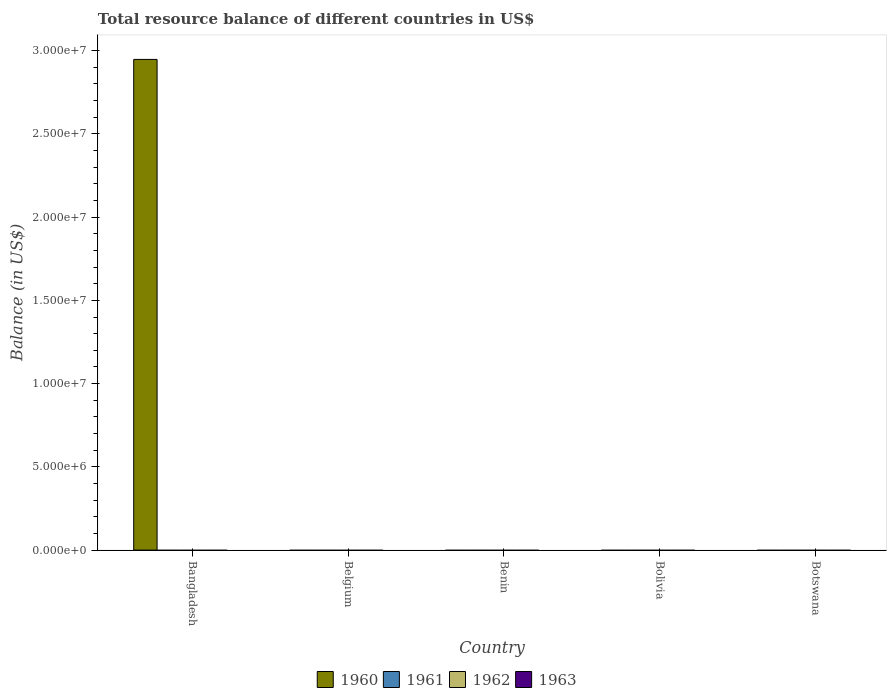How many different coloured bars are there?
Your answer should be compact. 1. How many bars are there on the 2nd tick from the right?
Ensure brevity in your answer.  0. What is the label of the 3rd group of bars from the left?
Offer a very short reply. Benin. What is the total resource balance in 1962 in Belgium?
Provide a succinct answer. 0. Across all countries, what is the maximum total resource balance in 1960?
Make the answer very short. 2.95e+07. Across all countries, what is the minimum total resource balance in 1961?
Your answer should be compact. 0. What is the total total resource balance in 1963 in the graph?
Make the answer very short. 0. What is the difference between the total resource balance in 1963 in Benin and the total resource balance in 1960 in Bangladesh?
Your response must be concise. -2.95e+07. What is the average total resource balance in 1960 per country?
Offer a terse response. 5.89e+06. In how many countries, is the total resource balance in 1960 greater than 19000000 US$?
Provide a short and direct response. 1. What is the difference between the highest and the lowest total resource balance in 1960?
Provide a succinct answer. 2.95e+07. Is it the case that in every country, the sum of the total resource balance in 1962 and total resource balance in 1961 is greater than the sum of total resource balance in 1960 and total resource balance in 1963?
Offer a very short reply. No. How many countries are there in the graph?
Ensure brevity in your answer.  5. What is the difference between two consecutive major ticks on the Y-axis?
Your answer should be very brief. 5.00e+06. Are the values on the major ticks of Y-axis written in scientific E-notation?
Your answer should be very brief. Yes. Does the graph contain grids?
Offer a terse response. No. How many legend labels are there?
Provide a short and direct response. 4. What is the title of the graph?
Keep it short and to the point. Total resource balance of different countries in US$. Does "2009" appear as one of the legend labels in the graph?
Provide a short and direct response. No. What is the label or title of the X-axis?
Provide a short and direct response. Country. What is the label or title of the Y-axis?
Your answer should be compact. Balance (in US$). What is the Balance (in US$) in 1960 in Bangladesh?
Your answer should be very brief. 2.95e+07. What is the Balance (in US$) in 1960 in Belgium?
Give a very brief answer. 0. What is the Balance (in US$) in 1961 in Belgium?
Provide a short and direct response. 0. What is the Balance (in US$) in 1962 in Belgium?
Keep it short and to the point. 0. What is the Balance (in US$) in 1963 in Belgium?
Keep it short and to the point. 0. What is the Balance (in US$) in 1960 in Bolivia?
Your answer should be very brief. 0. What is the Balance (in US$) in 1961 in Bolivia?
Offer a terse response. 0. What is the Balance (in US$) in 1962 in Bolivia?
Give a very brief answer. 0. What is the Balance (in US$) in 1963 in Bolivia?
Keep it short and to the point. 0. What is the Balance (in US$) in 1960 in Botswana?
Offer a terse response. 0. What is the Balance (in US$) in 1961 in Botswana?
Give a very brief answer. 0. Across all countries, what is the maximum Balance (in US$) of 1960?
Make the answer very short. 2.95e+07. What is the total Balance (in US$) in 1960 in the graph?
Your response must be concise. 2.95e+07. What is the total Balance (in US$) of 1961 in the graph?
Offer a very short reply. 0. What is the total Balance (in US$) of 1962 in the graph?
Make the answer very short. 0. What is the average Balance (in US$) of 1960 per country?
Your response must be concise. 5.89e+06. What is the average Balance (in US$) of 1961 per country?
Give a very brief answer. 0. What is the difference between the highest and the lowest Balance (in US$) in 1960?
Provide a succinct answer. 2.95e+07. 